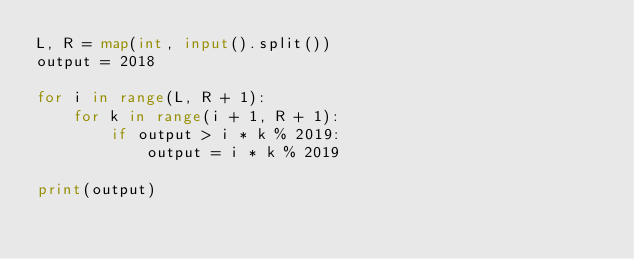<code> <loc_0><loc_0><loc_500><loc_500><_Python_>L, R = map(int, input().split())
output = 2018

for i in range(L, R + 1):
    for k in range(i + 1, R + 1):
        if output > i * k % 2019:
            output = i * k % 2019
            
print(output)</code> 